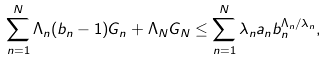Convert formula to latex. <formula><loc_0><loc_0><loc_500><loc_500>\sum ^ { N } _ { n = 1 } \Lambda _ { n } ( b _ { n } - 1 ) G _ { n } + \Lambda _ { N } G _ { N } \leq \sum ^ { N } _ { n = 1 } \lambda _ { n } a _ { n } b ^ { \Lambda _ { n } / \lambda _ { n } } _ { n } ,</formula> 